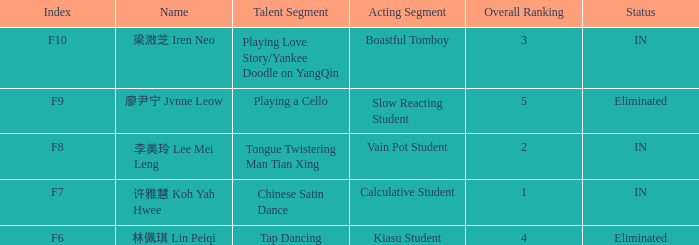Can you provide the status for the event labeled as f7? IN. 